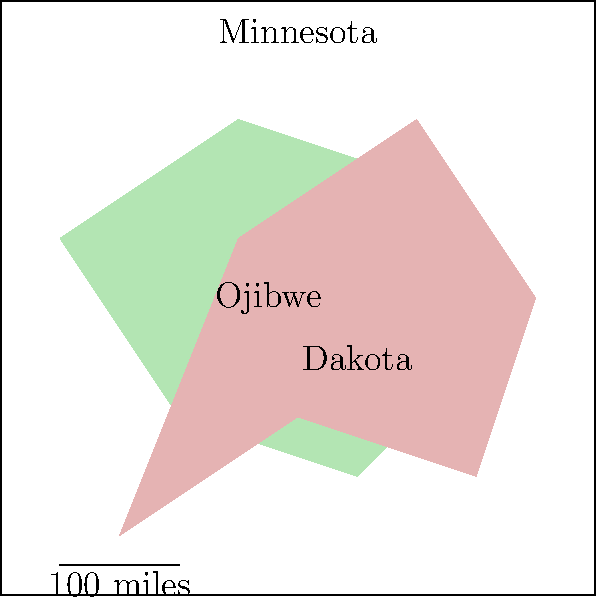Based on the map of Native American tribal territories in Minnesota, which tribe appears to have a larger territory? To determine which tribe has a larger territory, we need to compare the areas occupied by each tribe on the map. Let's analyze the map step-by-step:

1. Identify the two tribal territories:
   - The green area represents the Ojibwe territory
   - The pink area represents the Dakota territory

2. Observe the shape and extent of each territory:
   - The Ojibwe territory is concentrated in the northern part of the state
   - The Dakota territory extends from the southern to the central part of the state

3. Compare the visual size of the territories:
   - The Dakota territory appears to cover a larger area on the map
   - It extends further across the state in multiple directions

4. Consider the map's scale:
   - The scale provided shows 100 miles
   - Using this scale as a reference, we can see that the Dakota territory spans a greater distance both north-south and east-west

5. Analyze the overlap:
   - There is some overlap between the two territories in the central part of the state
   - Even with this overlap, the Dakota territory still appears larger

Based on these observations, we can conclude that the Dakota tribe appears to have a larger territory on this map of Minnesota.
Answer: Dakota 